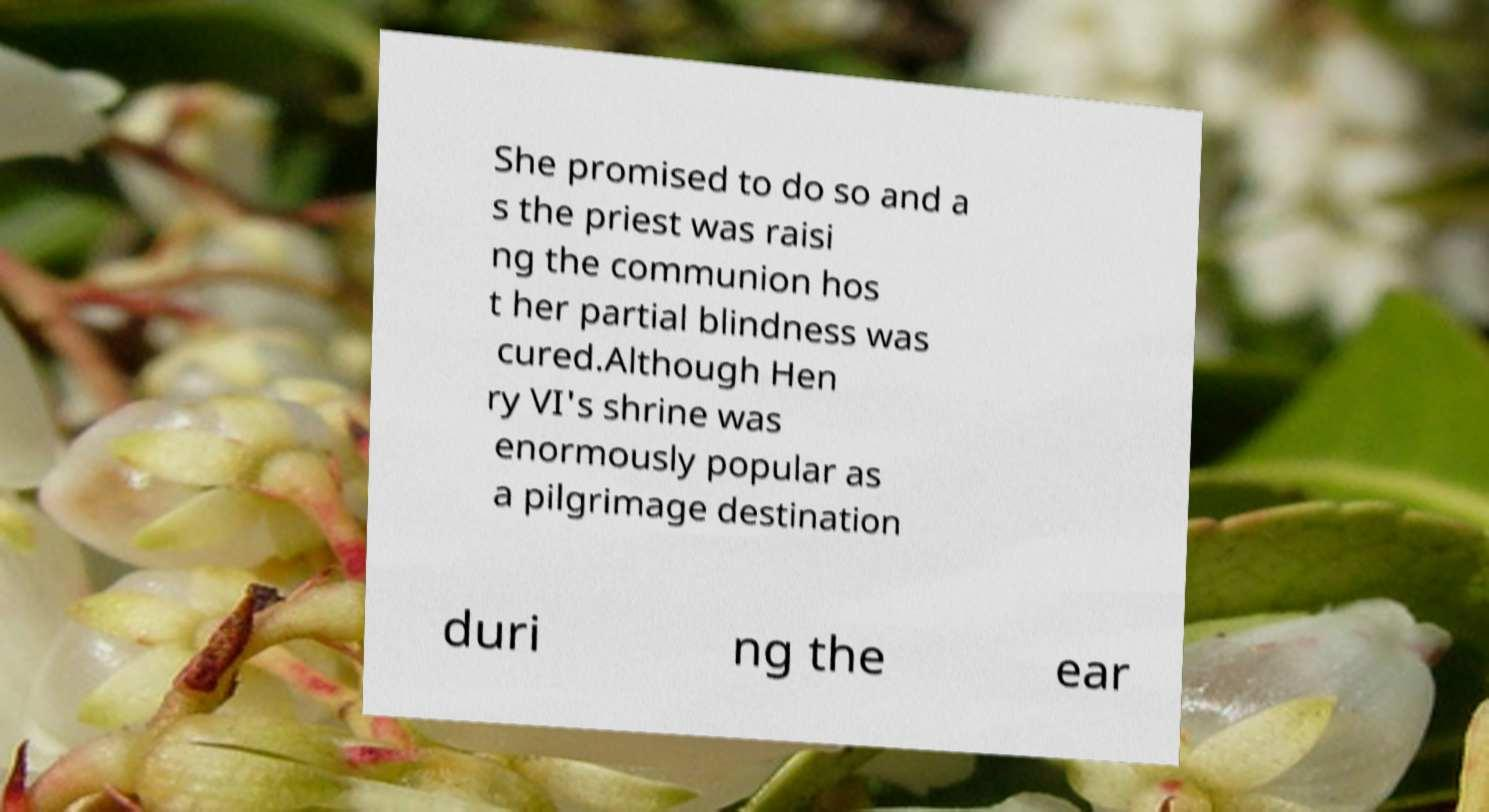What messages or text are displayed in this image? I need them in a readable, typed format. She promised to do so and a s the priest was raisi ng the communion hos t her partial blindness was cured.Although Hen ry VI's shrine was enormously popular as a pilgrimage destination duri ng the ear 